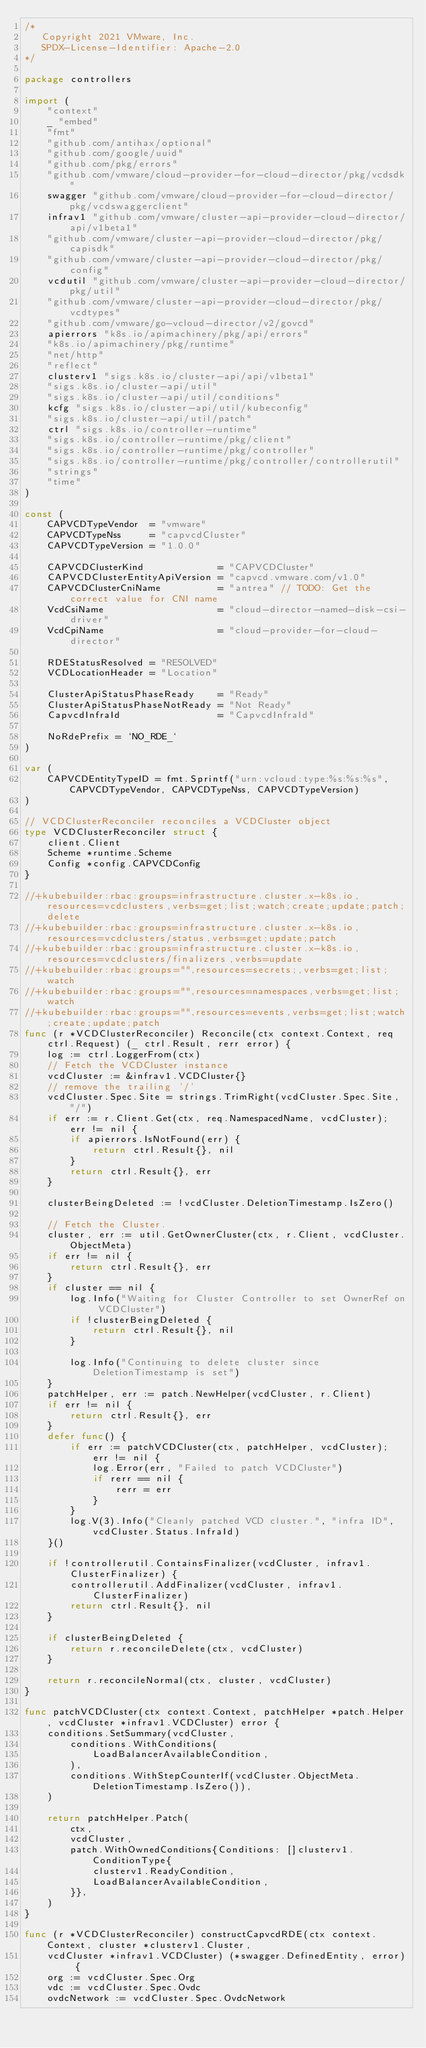<code> <loc_0><loc_0><loc_500><loc_500><_Go_>/*
   Copyright 2021 VMware, Inc.
   SPDX-License-Identifier: Apache-2.0
*/

package controllers

import (
	"context"
	_ "embed"
	"fmt"
	"github.com/antihax/optional"
	"github.com/google/uuid"
	"github.com/pkg/errors"
	"github.com/vmware/cloud-provider-for-cloud-director/pkg/vcdsdk"
	swagger "github.com/vmware/cloud-provider-for-cloud-director/pkg/vcdswaggerclient"
	infrav1 "github.com/vmware/cluster-api-provider-cloud-director/api/v1beta1"
	"github.com/vmware/cluster-api-provider-cloud-director/pkg/capisdk"
	"github.com/vmware/cluster-api-provider-cloud-director/pkg/config"
	vcdutil "github.com/vmware/cluster-api-provider-cloud-director/pkg/util"
	"github.com/vmware/cluster-api-provider-cloud-director/pkg/vcdtypes"
	"github.com/vmware/go-vcloud-director/v2/govcd"
	apierrors "k8s.io/apimachinery/pkg/api/errors"
	"k8s.io/apimachinery/pkg/runtime"
	"net/http"
	"reflect"
	clusterv1 "sigs.k8s.io/cluster-api/api/v1beta1"
	"sigs.k8s.io/cluster-api/util"
	"sigs.k8s.io/cluster-api/util/conditions"
	kcfg "sigs.k8s.io/cluster-api/util/kubeconfig"
	"sigs.k8s.io/cluster-api/util/patch"
	ctrl "sigs.k8s.io/controller-runtime"
	"sigs.k8s.io/controller-runtime/pkg/client"
	"sigs.k8s.io/controller-runtime/pkg/controller"
	"sigs.k8s.io/controller-runtime/pkg/controller/controllerutil"
	"strings"
	"time"
)

const (
	CAPVCDTypeVendor  = "vmware"
	CAPVCDTypeNss     = "capvcdCluster"
	CAPVCDTypeVersion = "1.0.0"

	CAPVCDClusterKind             = "CAPVCDCluster"
	CAPVCDClusterEntityApiVersion = "capvcd.vmware.com/v1.0"
	CAPVCDClusterCniName          = "antrea" // TODO: Get the correct value for CNI name
	VcdCsiName                    = "cloud-director-named-disk-csi-driver"
	VcdCpiName                    = "cloud-provider-for-cloud-director"

	RDEStatusResolved = "RESOLVED"
	VCDLocationHeader = "Location"

	ClusterApiStatusPhaseReady    = "Ready"
	ClusterApiStatusPhaseNotReady = "Not Ready"
	CapvcdInfraId                 = "CapvcdInfraId"

	NoRdePrefix = `NO_RDE_`
)

var (
	CAPVCDEntityTypeID = fmt.Sprintf("urn:vcloud:type:%s:%s:%s", CAPVCDTypeVendor, CAPVCDTypeNss, CAPVCDTypeVersion)
)

// VCDClusterReconciler reconciles a VCDCluster object
type VCDClusterReconciler struct {
	client.Client
	Scheme *runtime.Scheme
	Config *config.CAPVCDConfig
}

//+kubebuilder:rbac:groups=infrastructure.cluster.x-k8s.io,resources=vcdclusters,verbs=get;list;watch;create;update;patch;delete
//+kubebuilder:rbac:groups=infrastructure.cluster.x-k8s.io,resources=vcdclusters/status,verbs=get;update;patch
//+kubebuilder:rbac:groups=infrastructure.cluster.x-k8s.io,resources=vcdclusters/finalizers,verbs=update
//+kubebuilder:rbac:groups="",resources=secrets;,verbs=get;list;watch
//+kubebuilder:rbac:groups="",resources=namespaces,verbs=get;list;watch
//+kubebuilder:rbac:groups="",resources=events,verbs=get;list;watch;create;update;patch
func (r *VCDClusterReconciler) Reconcile(ctx context.Context, req ctrl.Request) (_ ctrl.Result, rerr error) {
	log := ctrl.LoggerFrom(ctx)
	// Fetch the VCDCluster instance
	vcdCluster := &infrav1.VCDCluster{}
	// remove the trailing '/'
	vcdCluster.Spec.Site = strings.TrimRight(vcdCluster.Spec.Site, "/")
	if err := r.Client.Get(ctx, req.NamespacedName, vcdCluster); err != nil {
		if apierrors.IsNotFound(err) {
			return ctrl.Result{}, nil
		}
		return ctrl.Result{}, err
	}

	clusterBeingDeleted := !vcdCluster.DeletionTimestamp.IsZero()

	// Fetch the Cluster.
	cluster, err := util.GetOwnerCluster(ctx, r.Client, vcdCluster.ObjectMeta)
	if err != nil {
		return ctrl.Result{}, err
	}
	if cluster == nil {
		log.Info("Waiting for Cluster Controller to set OwnerRef on VCDCluster")
		if !clusterBeingDeleted {
			return ctrl.Result{}, nil
		}

		log.Info("Continuing to delete cluster since DeletionTimestamp is set")
	}
	patchHelper, err := patch.NewHelper(vcdCluster, r.Client)
	if err != nil {
		return ctrl.Result{}, err
	}
	defer func() {
		if err := patchVCDCluster(ctx, patchHelper, vcdCluster); err != nil {
			log.Error(err, "Failed to patch VCDCluster")
			if rerr == nil {
				rerr = err
			}
		}
		log.V(3).Info("Cleanly patched VCD cluster.", "infra ID", vcdCluster.Status.InfraId)
	}()

	if !controllerutil.ContainsFinalizer(vcdCluster, infrav1.ClusterFinalizer) {
		controllerutil.AddFinalizer(vcdCluster, infrav1.ClusterFinalizer)
		return ctrl.Result{}, nil
	}

	if clusterBeingDeleted {
		return r.reconcileDelete(ctx, vcdCluster)
	}

	return r.reconcileNormal(ctx, cluster, vcdCluster)
}

func patchVCDCluster(ctx context.Context, patchHelper *patch.Helper, vcdCluster *infrav1.VCDCluster) error {
	conditions.SetSummary(vcdCluster,
		conditions.WithConditions(
			LoadBalancerAvailableCondition,
		),
		conditions.WithStepCounterIf(vcdCluster.ObjectMeta.DeletionTimestamp.IsZero()),
	)

	return patchHelper.Patch(
		ctx,
		vcdCluster,
		patch.WithOwnedConditions{Conditions: []clusterv1.ConditionType{
			clusterv1.ReadyCondition,
			LoadBalancerAvailableCondition,
		}},
	)
}

func (r *VCDClusterReconciler) constructCapvcdRDE(ctx context.Context, cluster *clusterv1.Cluster,
	vcdCluster *infrav1.VCDCluster) (*swagger.DefinedEntity, error) {
	org := vcdCluster.Spec.Org
	vdc := vcdCluster.Spec.Ovdc
	ovdcNetwork := vcdCluster.Spec.OvdcNetwork
</code> 